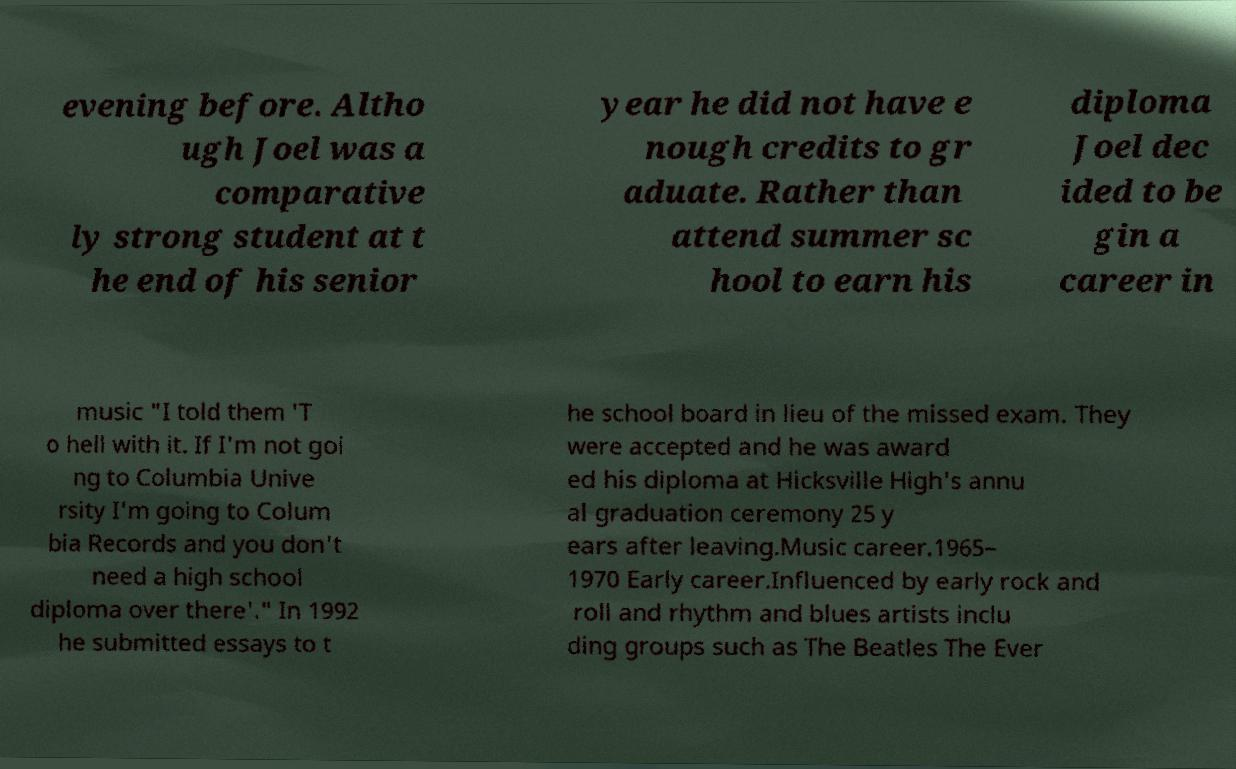Could you extract and type out the text from this image? evening before. Altho ugh Joel was a comparative ly strong student at t he end of his senior year he did not have e nough credits to gr aduate. Rather than attend summer sc hool to earn his diploma Joel dec ided to be gin a career in music "I told them 'T o hell with it. If I'm not goi ng to Columbia Unive rsity I'm going to Colum bia Records and you don't need a high school diploma over there'." In 1992 he submitted essays to t he school board in lieu of the missed exam. They were accepted and he was award ed his diploma at Hicksville High's annu al graduation ceremony 25 y ears after leaving.Music career.1965– 1970 Early career.Influenced by early rock and roll and rhythm and blues artists inclu ding groups such as The Beatles The Ever 